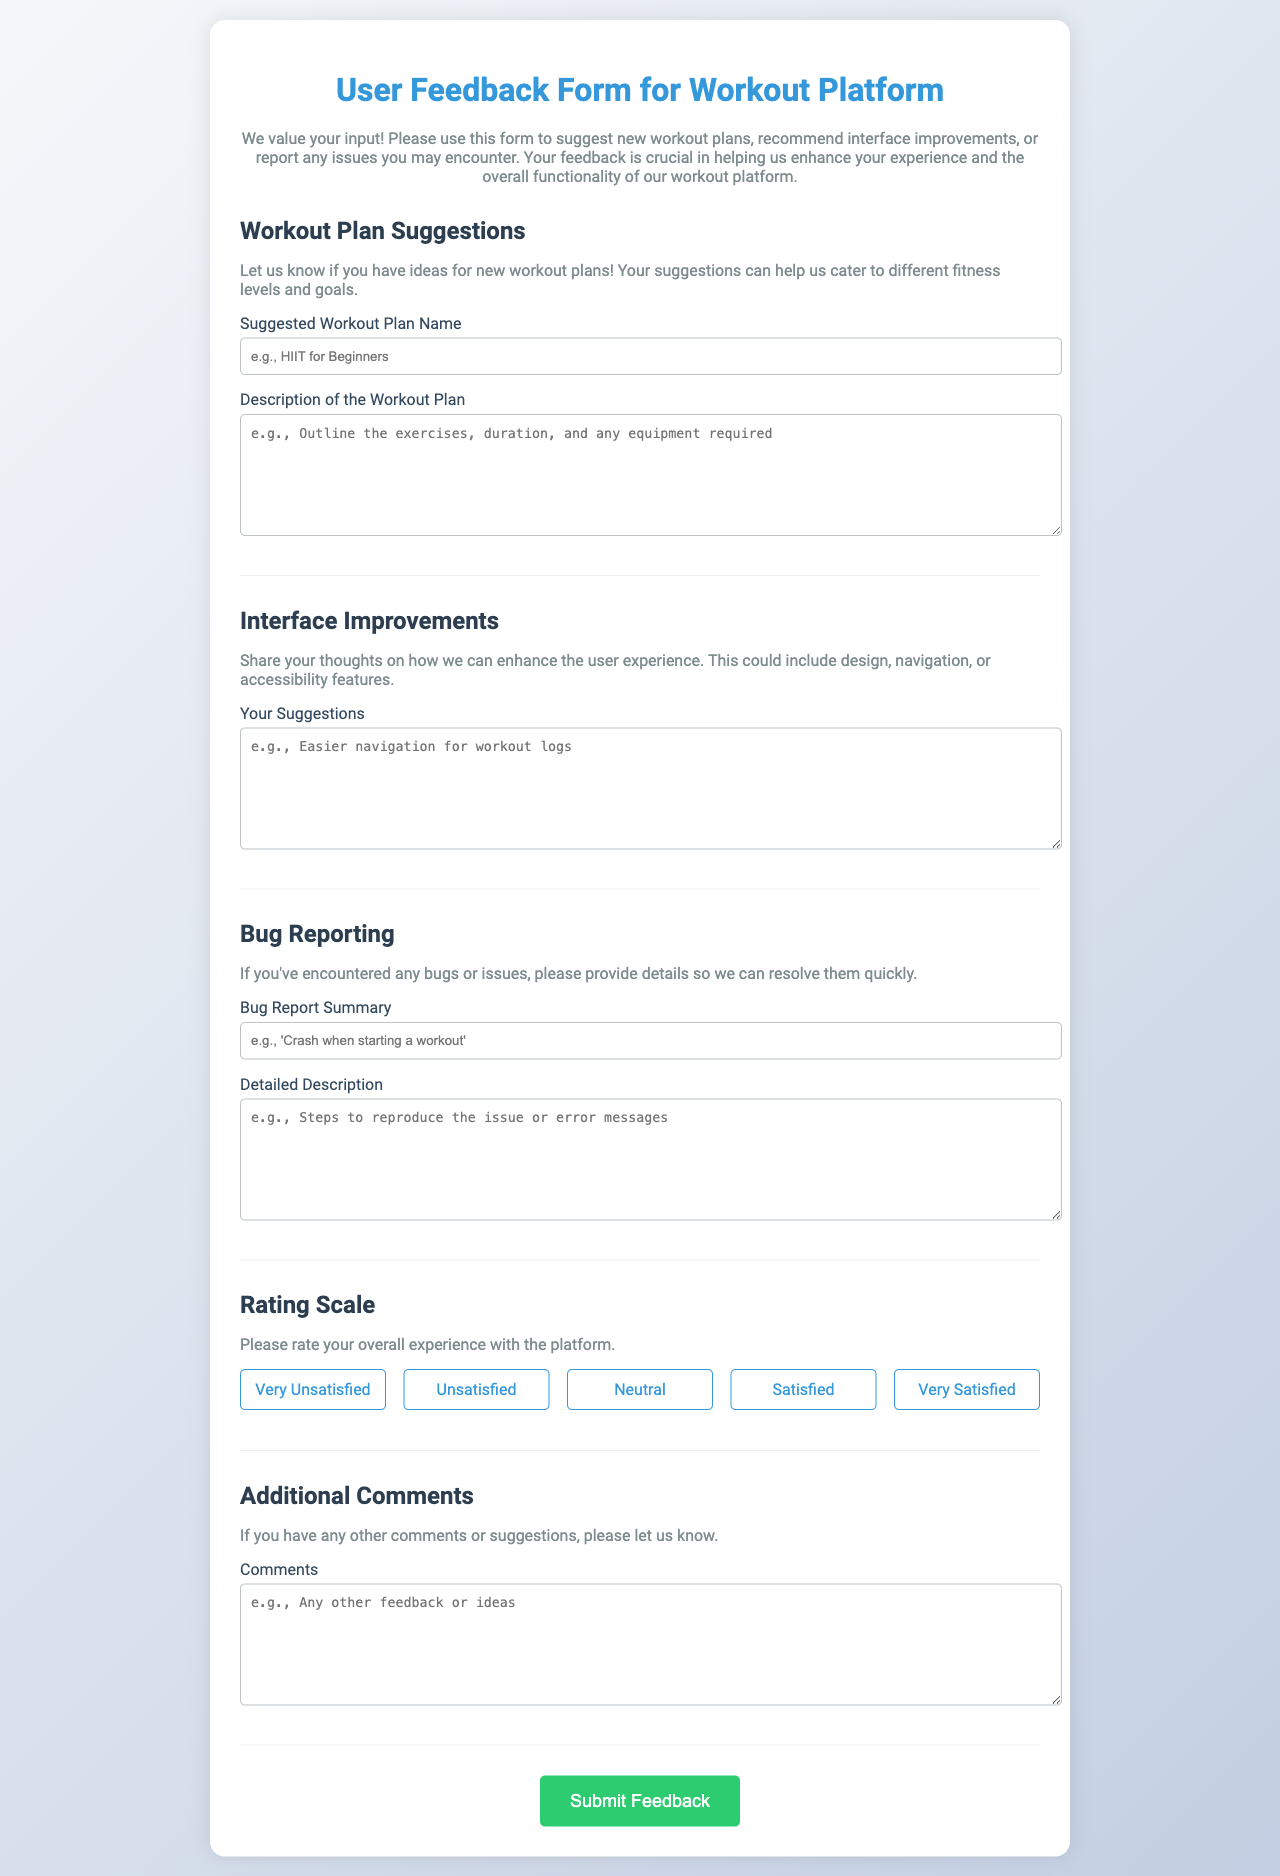what is the title of the form? The title of the form is displayed prominently at the top of the document.
Answer: User Feedback Form for Workout Platform how many sections are there in the form? The form is divided into multiple sections, each addressing different types of feedback.
Answer: 5 what is the first section about? The first section of the form is dedicated to collecting suggestions for workout plans.
Answer: Workout Plan Suggestions what is the placeholder text for the 'Bug Report Summary' input? The placeholder text provides an example of what users can enter in that input field.
Answer: 'Crash when starting a workout' what type of input does the 'Rating Scale' section include? This section includes a specific type of input intended for users to provide a rating of their experience.
Answer: Radio buttons what color is the submit button? The color of the button helps in attracting the users' attention to the action they need to take.
Answer: Green what description is provided in the 'Interface Improvements' section? The description in this section encourages users to provide their thoughts about enhancing user experience.
Answer: Share your thoughts on how we can enhance the user experience which rating corresponds to 'Very Satisfied'? The ratings in the form are associated with specific levels of satisfaction based on user experience.
Answer: 5 